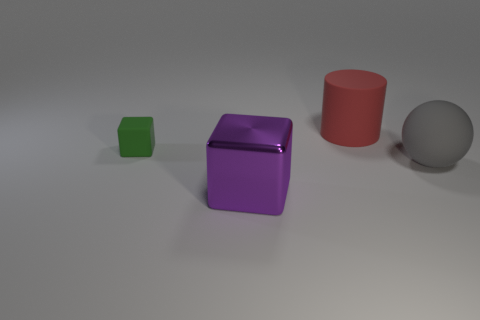What number of other objects are the same material as the purple object?
Provide a succinct answer. 0. There is a cube that is behind the big sphere; how big is it?
Give a very brief answer. Small. The gray thing that is made of the same material as the small green object is what shape?
Your answer should be very brief. Sphere. Does the big cylinder have the same material as the cube that is behind the big gray object?
Offer a very short reply. Yes. Does the matte thing that is left of the large red cylinder have the same shape as the big purple thing?
Provide a succinct answer. Yes. What is the material of the other thing that is the same shape as the big metal object?
Keep it short and to the point. Rubber. Is the shape of the tiny thing the same as the large object behind the gray matte thing?
Your answer should be very brief. No. There is a large thing that is both behind the big purple block and on the left side of the large gray thing; what is its color?
Provide a short and direct response. Red. Are there any large yellow matte cubes?
Offer a very short reply. No. Are there the same number of purple blocks in front of the gray thing and small gray blocks?
Make the answer very short. No. 